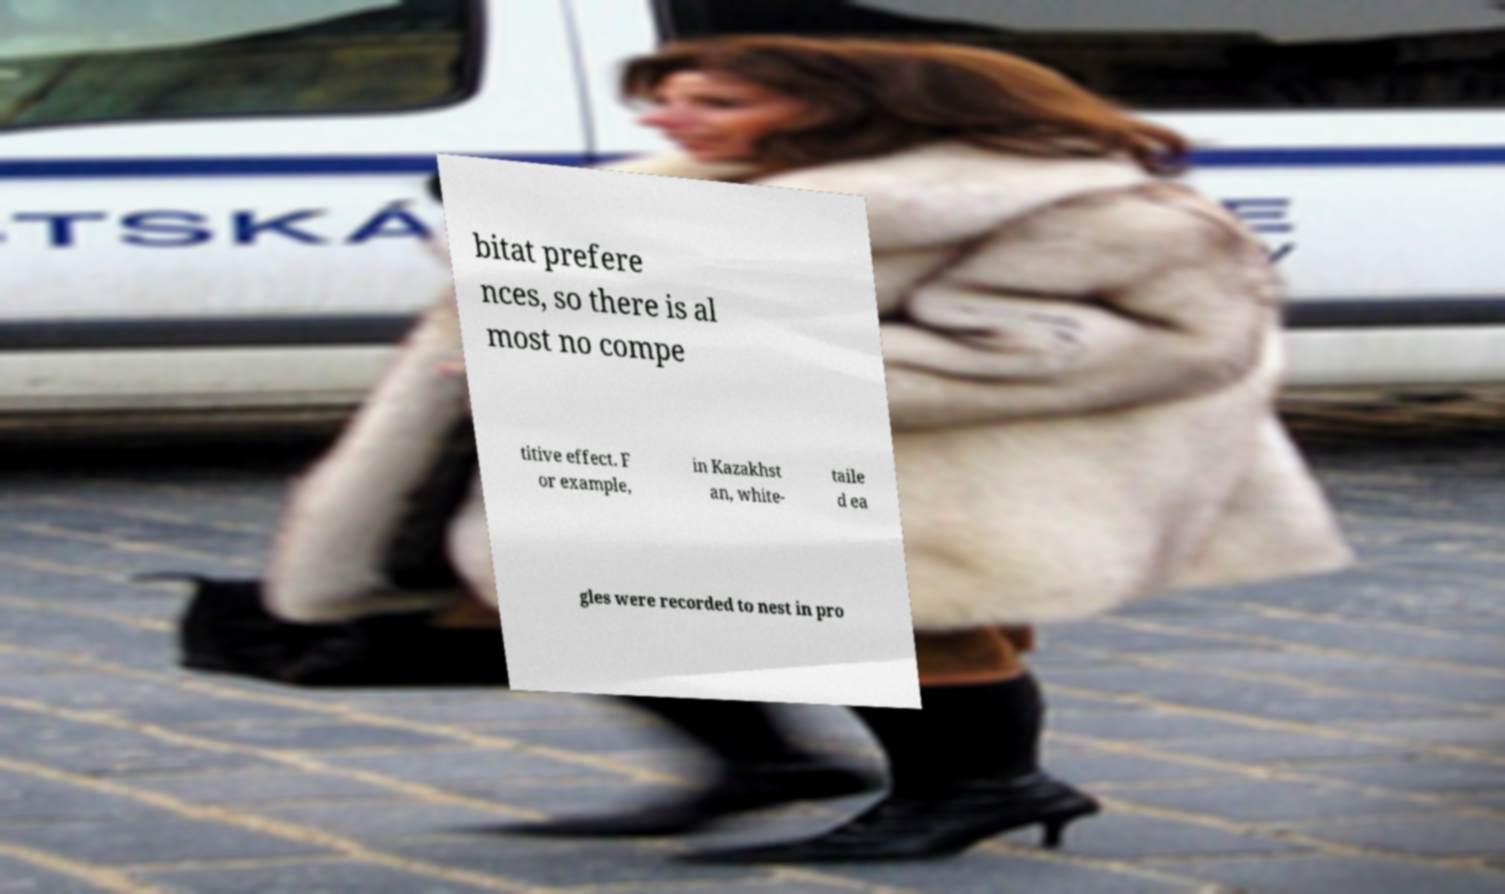Please identify and transcribe the text found in this image. bitat prefere nces, so there is al most no compe titive effect. F or example, in Kazakhst an, white- taile d ea gles were recorded to nest in pro 